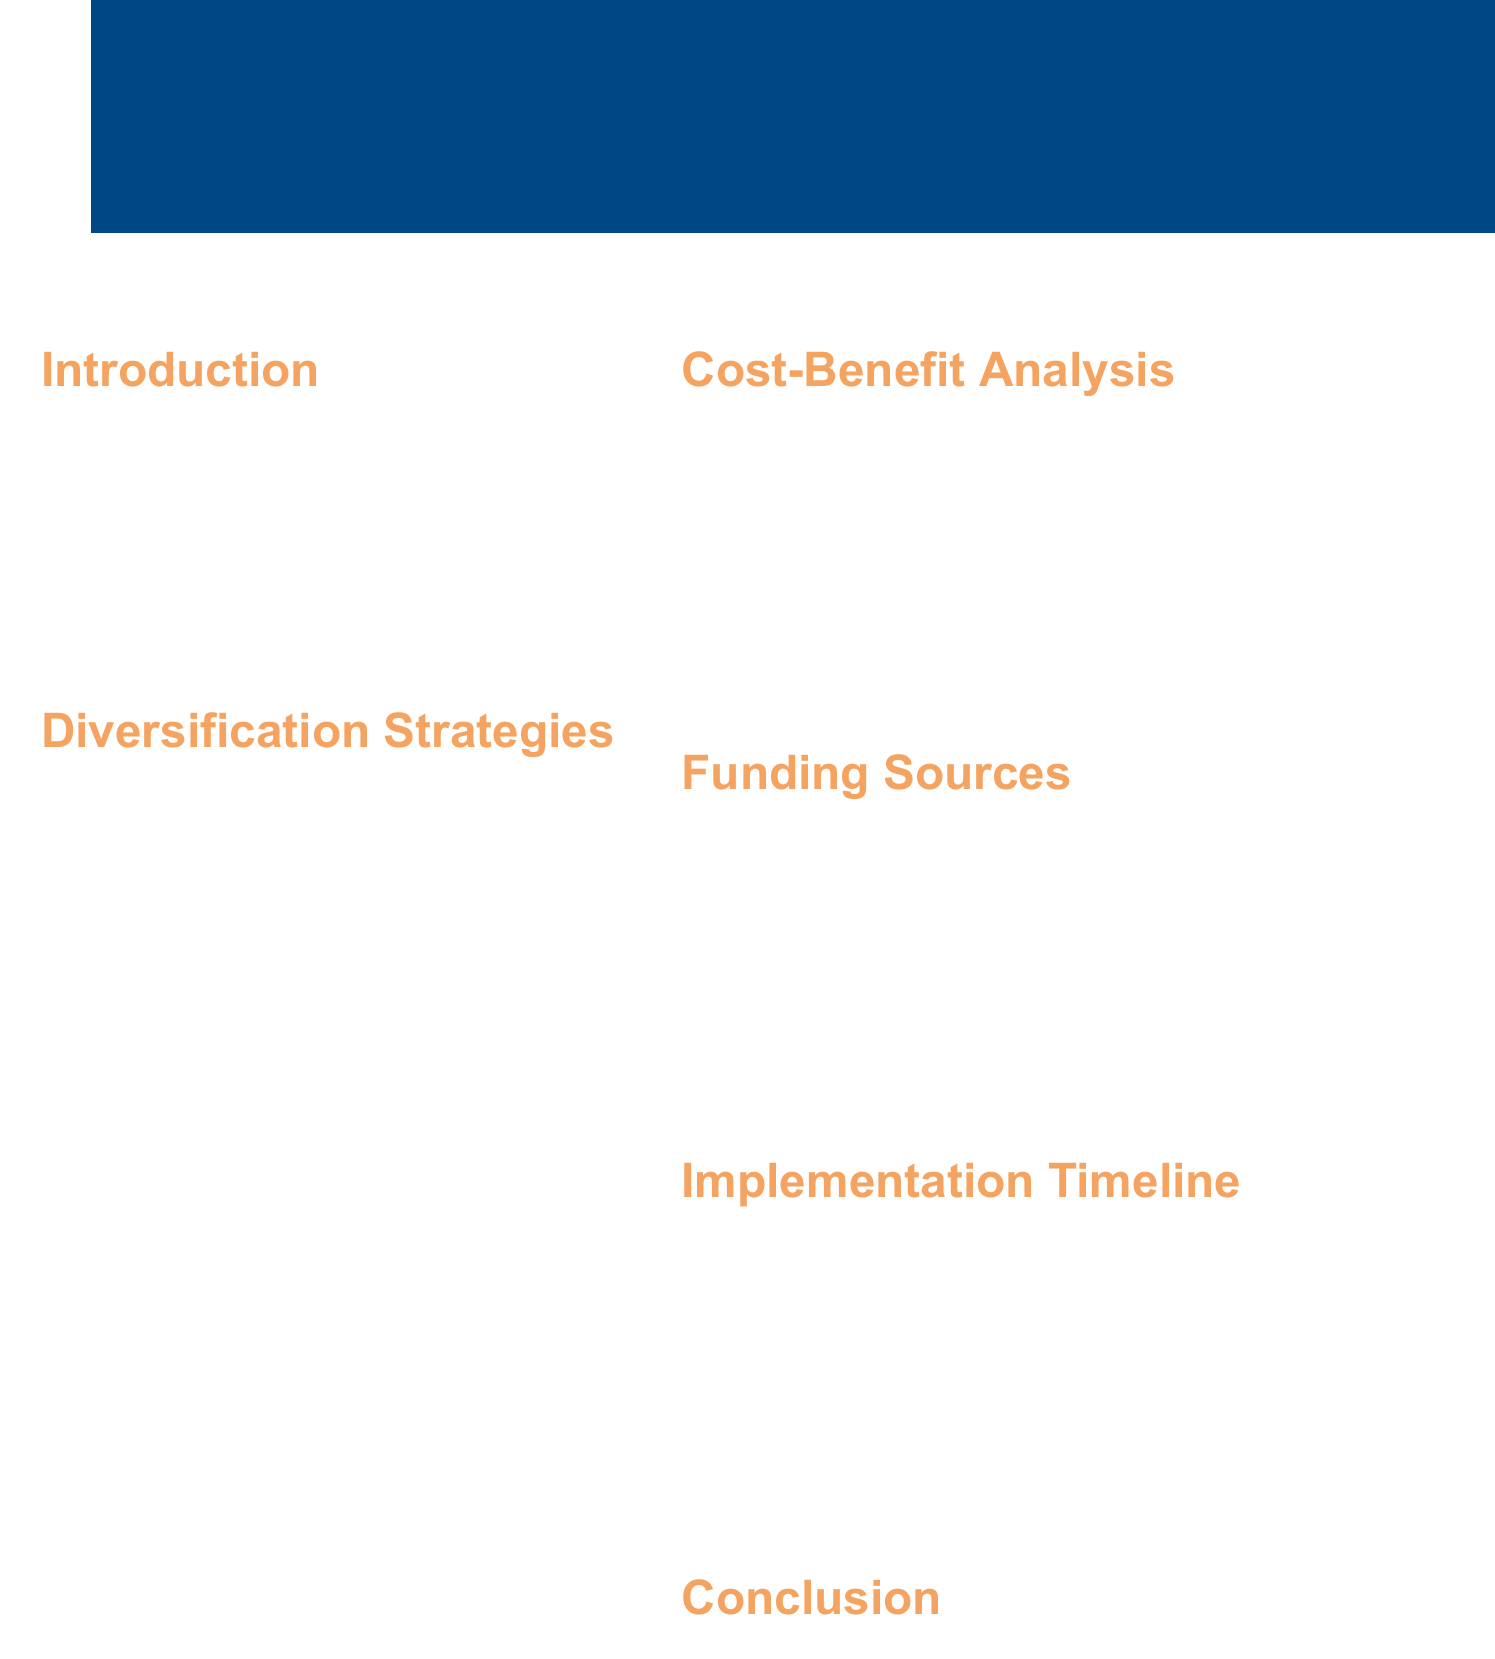What is the population of Oakridge? The population of Oakridge is provided in the introduction section of the document, which states that it is 25,000.
Answer: 25,000 What is the estimated cost for Renewable Energy Manufacturing? The estimated cost for Renewable Energy Manufacturing is listed in the diversification strategies section of the document.
Answer: $50 million What is the projected annual return from all diversification strategies? The projected annual return is mentioned in the cost-benefit analysis section, indicating the financial benefit expected from the investments.
Answer: $175 million How many new jobs are expected to be created through the Tourism Enhancement strategy? The number of new jobs created by the Tourism Enhancement strategy is included in the description of that specific strategy.
Answer: 250 new jobs What is the payback period for the total investment? The payback period can be found in the cost-benefit analysis section of the document.
Answer: 3.5 years What is the total investment amount for the diversification strategies? The total investment amount is summarized in the cost-benefit analysis section of the document.
Answer: $100 million What is the expected reduction in oil dependence within 5 years? The expected outcome regarding oil dependence is stated in the conclusion part of the document.
Answer: 40% Which funding source is mentioned first? The funding sources are listed in the document, and the first one mentioned is the Texas Enterprise Fund.
Answer: Texas Enterprise Fund What phase is scheduled for Planning and securing funding? The implementation timeline specifies the planning phase timeframe clearly.
Answer: Q3 2023 - Q2 2024 